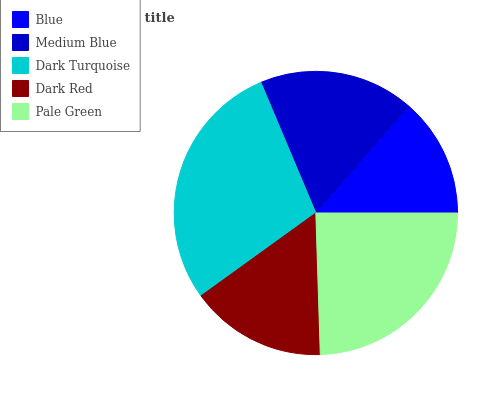Is Blue the minimum?
Answer yes or no. Yes. Is Dark Turquoise the maximum?
Answer yes or no. Yes. Is Medium Blue the minimum?
Answer yes or no. No. Is Medium Blue the maximum?
Answer yes or no. No. Is Medium Blue greater than Blue?
Answer yes or no. Yes. Is Blue less than Medium Blue?
Answer yes or no. Yes. Is Blue greater than Medium Blue?
Answer yes or no. No. Is Medium Blue less than Blue?
Answer yes or no. No. Is Medium Blue the high median?
Answer yes or no. Yes. Is Medium Blue the low median?
Answer yes or no. Yes. Is Dark Red the high median?
Answer yes or no. No. Is Blue the low median?
Answer yes or no. No. 